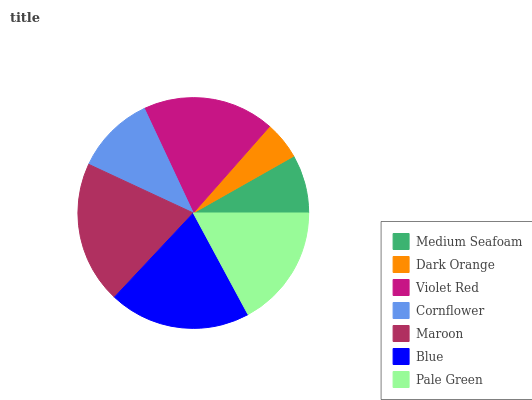Is Dark Orange the minimum?
Answer yes or no. Yes. Is Maroon the maximum?
Answer yes or no. Yes. Is Violet Red the minimum?
Answer yes or no. No. Is Violet Red the maximum?
Answer yes or no. No. Is Violet Red greater than Dark Orange?
Answer yes or no. Yes. Is Dark Orange less than Violet Red?
Answer yes or no. Yes. Is Dark Orange greater than Violet Red?
Answer yes or no. No. Is Violet Red less than Dark Orange?
Answer yes or no. No. Is Pale Green the high median?
Answer yes or no. Yes. Is Pale Green the low median?
Answer yes or no. Yes. Is Cornflower the high median?
Answer yes or no. No. Is Blue the low median?
Answer yes or no. No. 